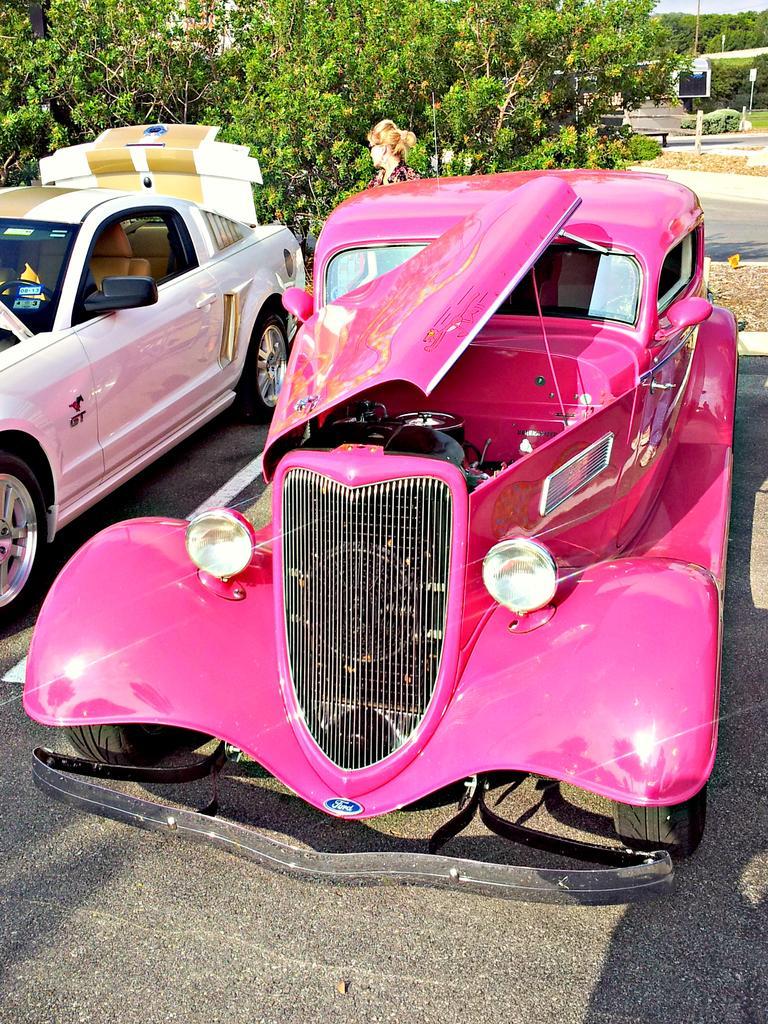Please provide a concise description of this image. In this image I can see two cars on the road. One is in pink color and one is in white color. At the back of these cars I can see a woman. In the background there are many trees. 